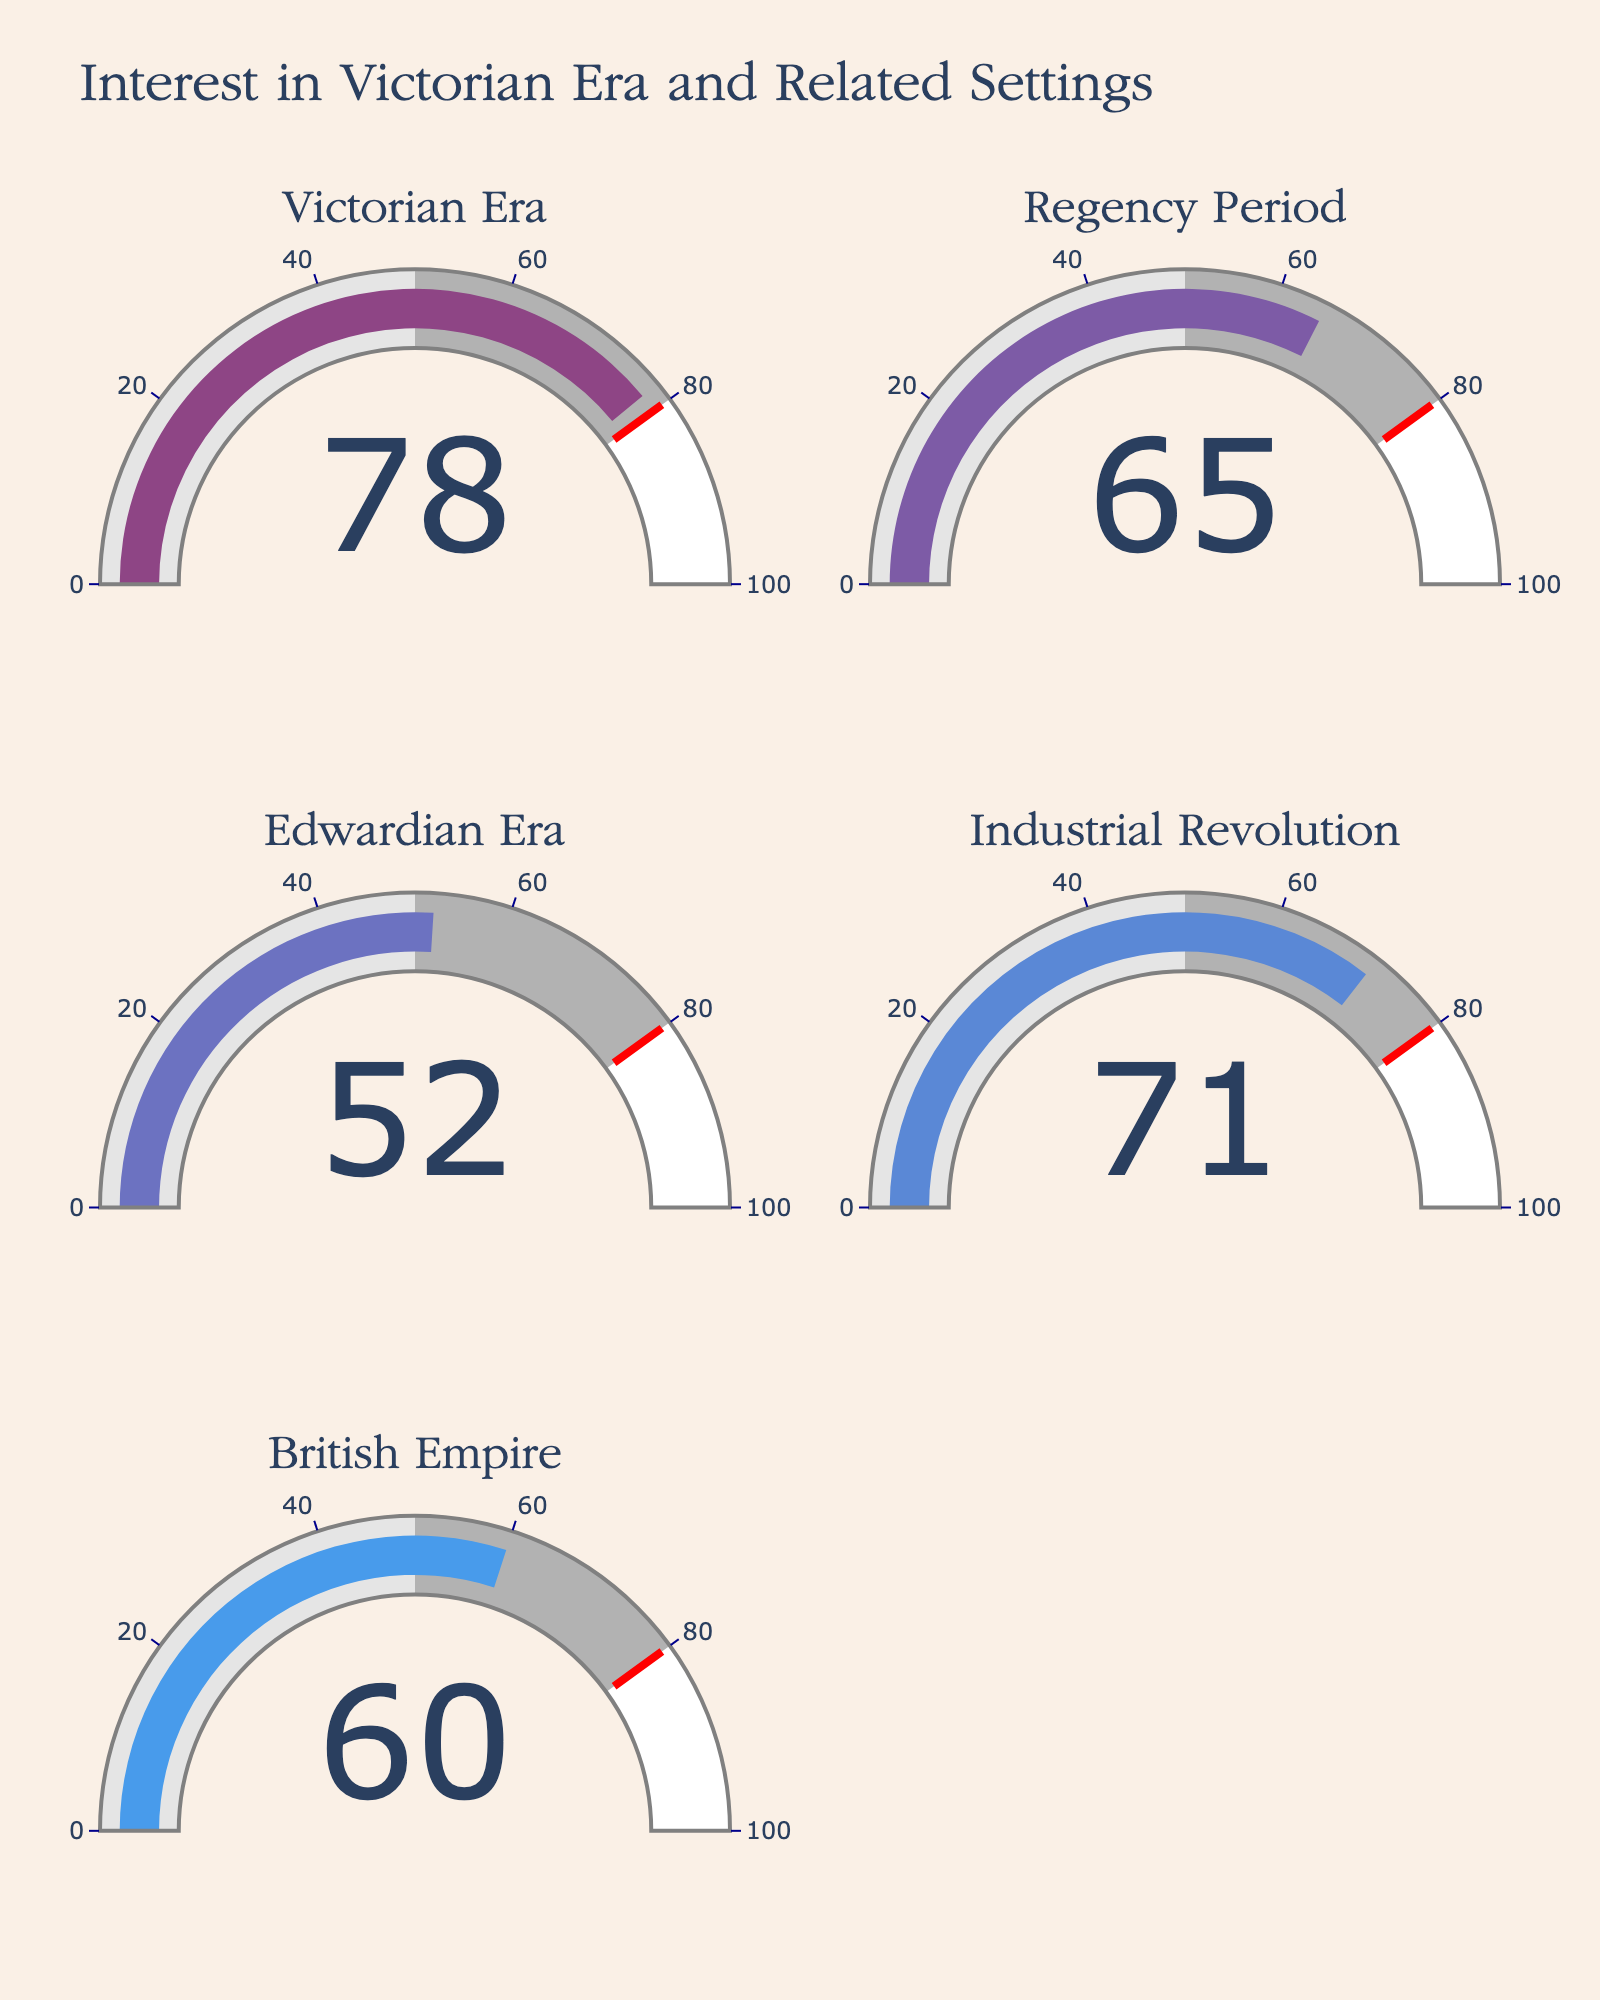what is the percentage interest for the Victorian Era? The gauge chart for the Victorian Era indicates a numerical value representing the interest percentage. This value is visually displayed within the gauge.
Answer: 78% what are the interest percentages for the Industrial Revolution and Edwardian Era combined? Identify the percentages from the gauges labeled "Industrial Revolution" and "Edwardian Era." Add these two values together: 71 (Industrial Revolution) + 52 (Edwardian Era) = 123.
Answer: 123 which two periods have an interest percentage greater than 70%? Check each gauge chart and note down the percentages. Identify which periods have percentages greater than 70. The Victorian Era has 78% and the Industrial Revolution has 71%.
Answer: Victorian Era, Industrial Revolution which period has the highest interest percentage? Compare the percentage values in each gauge chart. The Victorian Era shows the highest percentage at 78.
Answer: Victorian Era what is the average interest percentage across all periods displayed? Add up the percentages from all five periods and divide by the number of periods. Calculation: (78 + 65 + 52 + 71 + 60) / 5 = 65.2.
Answer: 65.2 is the interest in the Victorian Era more or less than double the interest in the Edwardian Era? Compare the interest percentages for both periods. Victorian Era: 78%, Edwardian Era: 52%. Check if 78 is less than double of 52 (i.e., 78 < 2 * 52, which is 104).
Answer: Less how many periods have an interest percentage below 70%? Check each gauge value to determine how many are below 70%. The percentages below 70 are 65% (Regency Period), 52% (Edwardian Era), and 60% (British Empire).
Answer: 3 what is the median interest percentage of the periods? List the percentages in order: 52, 60, 65, 71, 78. The median is the middle value in the ordered list.
Answer: 65 how much higher is the interest percentage for the Victorian Era compared to the British Empire? Calculate the difference between the percentages: Victorian Era (78) - British Empire (60) = 18.
Answer: 18 what portion of the gauges show a value above the threshold of 80? Check each gauge value to see if any of them exceed the threshold of 80. None of the gauges exceed 80, so the portion is 0 out of 5.
Answer: 0 portions 